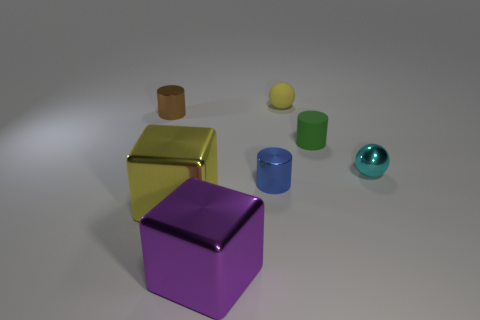Add 2 purple shiny balls. How many objects exist? 9 Subtract all tiny green cylinders. How many cylinders are left? 2 Add 7 tiny gray cylinders. How many tiny gray cylinders exist? 7 Subtract all green cylinders. How many cylinders are left? 2 Subtract 0 gray balls. How many objects are left? 7 Subtract all cylinders. How many objects are left? 4 Subtract 2 spheres. How many spheres are left? 0 Subtract all brown balls. Subtract all green cylinders. How many balls are left? 2 Subtract all green cubes. How many brown cylinders are left? 1 Subtract all purple things. Subtract all small shiny spheres. How many objects are left? 5 